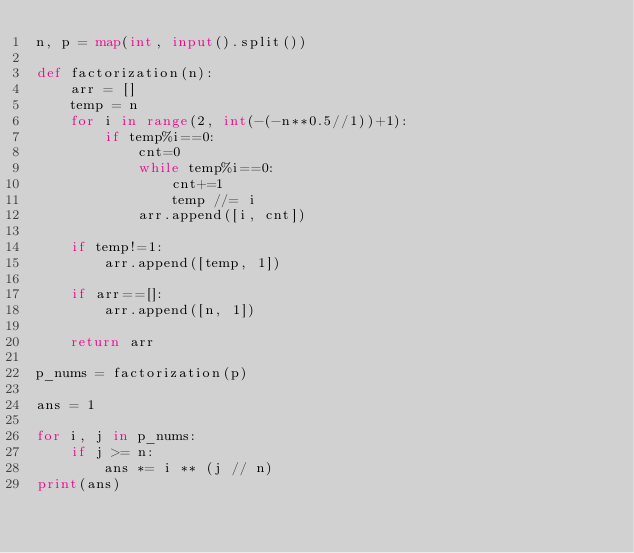<code> <loc_0><loc_0><loc_500><loc_500><_Python_>n, p = map(int, input().split())

def factorization(n):
    arr = []
    temp = n
    for i in range(2, int(-(-n**0.5//1))+1):
        if temp%i==0:
            cnt=0
            while temp%i==0:
                cnt+=1
                temp //= i
            arr.append([i, cnt])

    if temp!=1:
        arr.append([temp, 1])

    if arr==[]:
        arr.append([n, 1])

    return arr

p_nums = factorization(p)

ans = 1

for i, j in p_nums:
    if j >= n:
        ans *= i ** (j // n)
print(ans)
</code> 